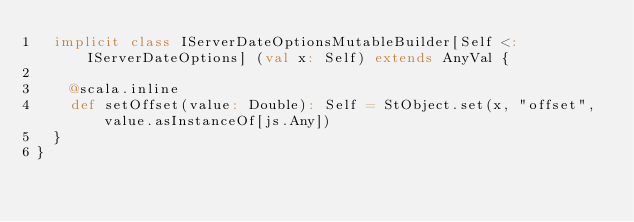Convert code to text. <code><loc_0><loc_0><loc_500><loc_500><_Scala_>  implicit class IServerDateOptionsMutableBuilder[Self <: IServerDateOptions] (val x: Self) extends AnyVal {
    
    @scala.inline
    def setOffset(value: Double): Self = StObject.set(x, "offset", value.asInstanceOf[js.Any])
  }
}
</code> 